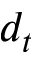<formula> <loc_0><loc_0><loc_500><loc_500>d _ { t }</formula> 